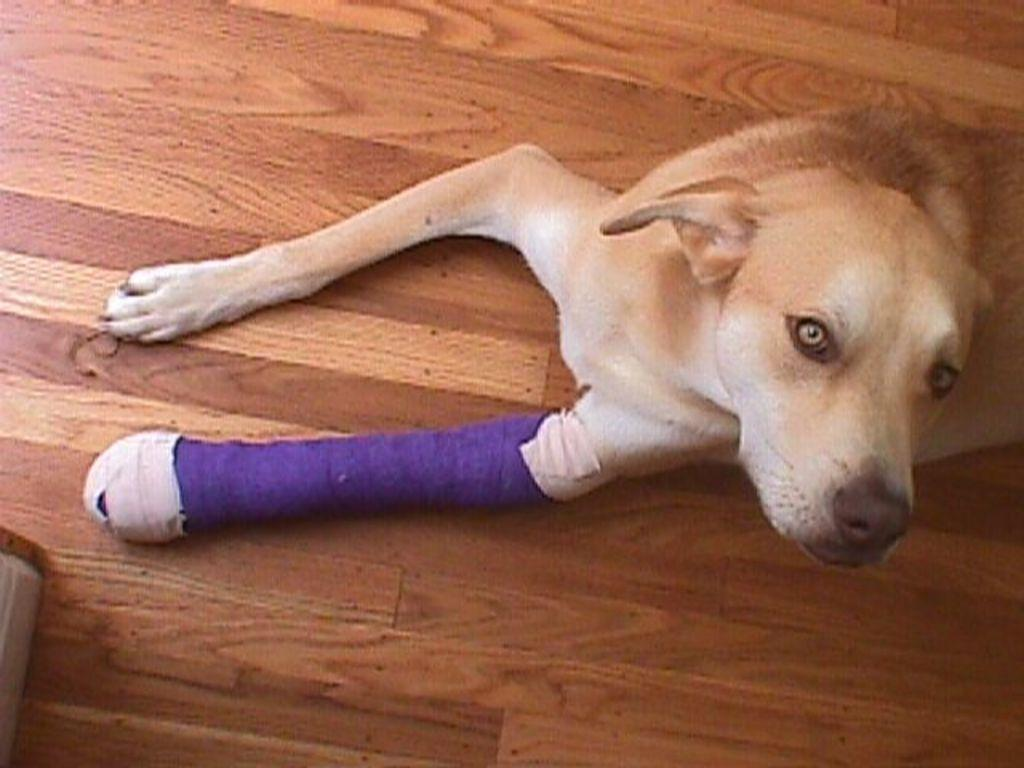What type of animal is in the image? There is a dog in the image. What colors can be seen on the dog? The dog is white and brown in color. Is there anything unique about the dog's appearance? Yes, the dog has a purple color band on its leg. What is the dog standing on in the image? The dog is on a brown color surface. What type of error can be seen in the image? There is no error present in the image; it is a clear picture of a dog. 